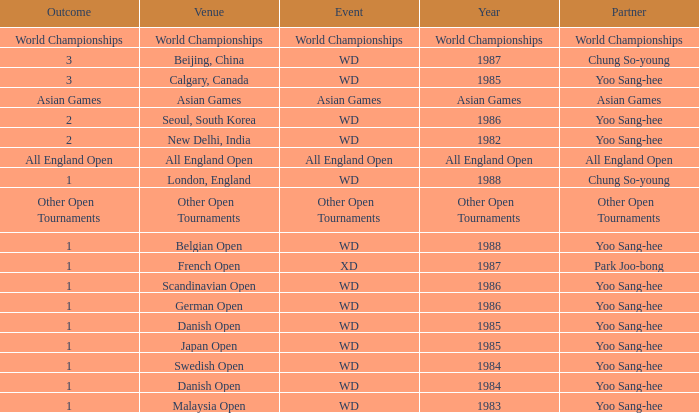What was the Venue in 1986 with an Outcome of 1? Scandinavian Open, German Open. 